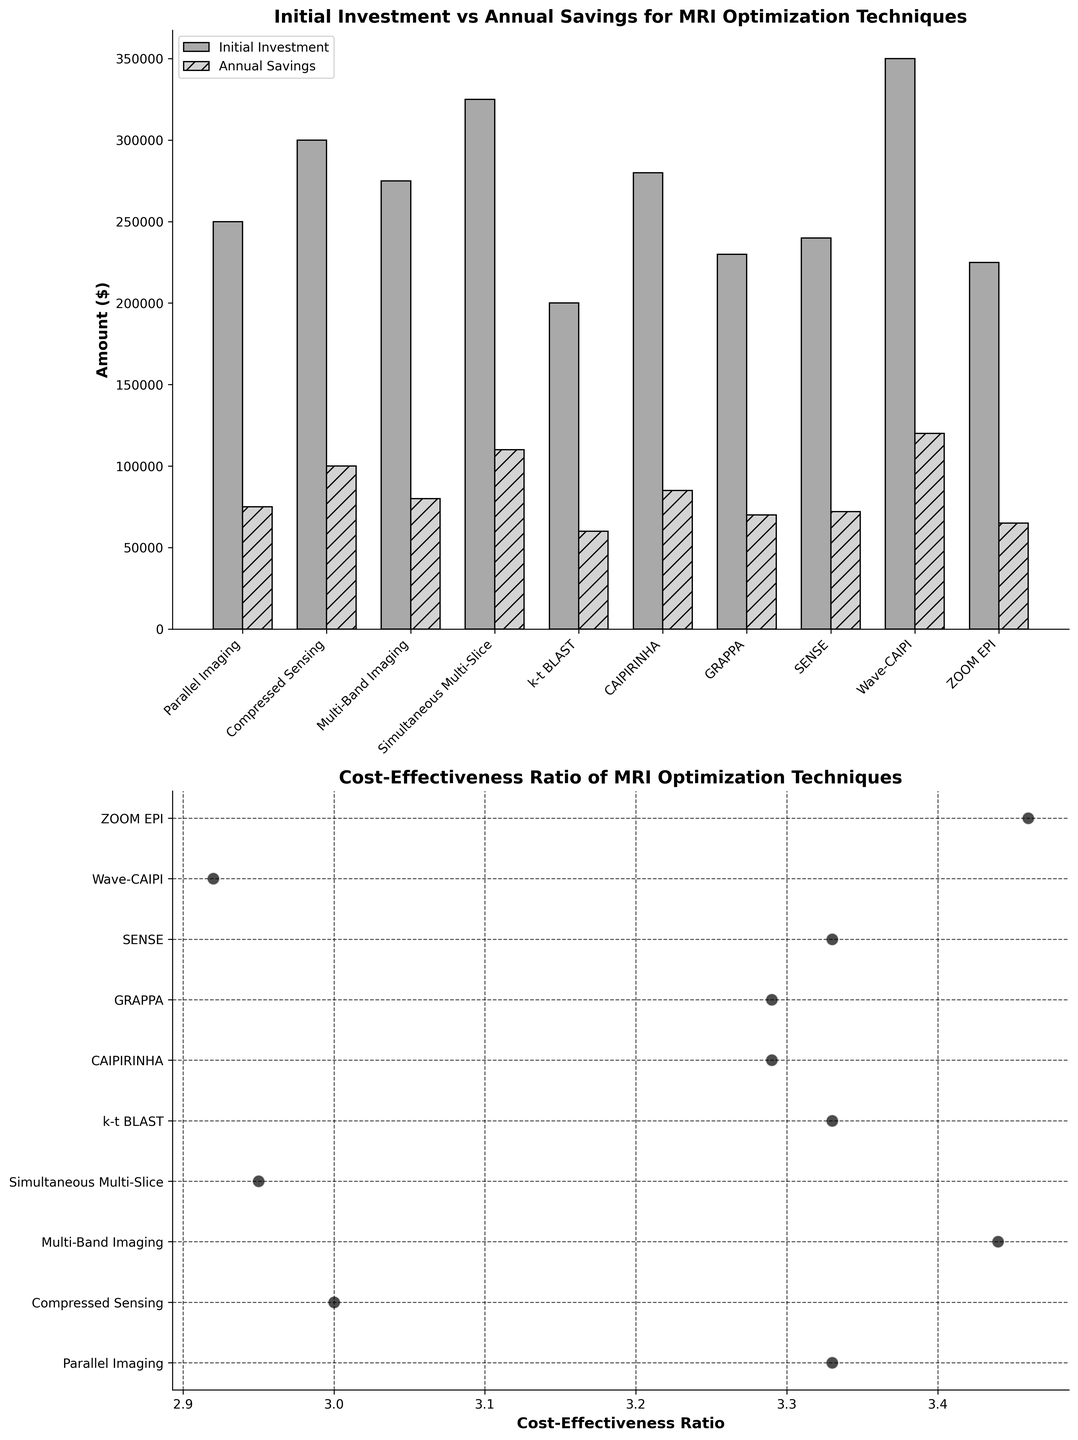What are the two parameters shown in the bar plot? The bar plot shows "Initial Investment" and "Annual Savings" for different MRI optimization techniques.
Answer: Initial Investment and Annual Savings How many MRI optimization techniques are compared in the bar plot? By counting the number of bars, we can see that there are 10 MRI optimization techniques compared.
Answer: 10 Which MRI technique has the highest Initial Investment? By looking at the height of the bars representing "Initial Investment," we see that "Wave-CAIPI" has the highest initial investment.
Answer: Wave-CAIPI What is the Cost-Effectiveness Ratio of the MRI technique with the lowest Annual Savings? By identifying the technique with the lowest "Annual Savings" from the bar plot, which is "k-t BLAST" ($60,000), we check the corresponding Cost-Effectiveness Ratio from the scatter plot. It's 3.33.
Answer: 3.33 Which MRI technique provides the highest Annual Savings and what is its Cost-Effectiveness Ratio? The technique with the highest Annual Savings is "Wave-CAIPI" with $120,000. Its Cost-Effectiveness Ratio, taken from the scatter plot, is 2.92.
Answer: Wave-CAIPI, 2.92 How does the Cost-Effectiveness Ratio of "GRAPPA" compare with "ZOOM EPI"? By observing the scatter plot, we find that both "GRAPPA" and "ZOOM EPI" have similar Cost-Effectiveness Ratios, around 3.29 and 3.46 respectively.
Answer: ZOOM EPI is greater What is the average Initial Investment across all MRI techniques? Summing the initial investments for all techniques and dividing by the number of techniques, (250000 + 300000 + 275000 + 325000 + 200000 + 280000 + 230000 + 240000 + 350000 + 225000) / 10 = 267500
Answer: 267500 What is the difference between the highest and lowest Cost-Effectiveness Ratios? The highest Cost-Effectiveness Ratio is 3.46 (ZOOM EPI), and the lowest is 2.92 (Wave-CAIPI). The difference is 3.46 - 2.92 = 0.54.
Answer: 0.54 